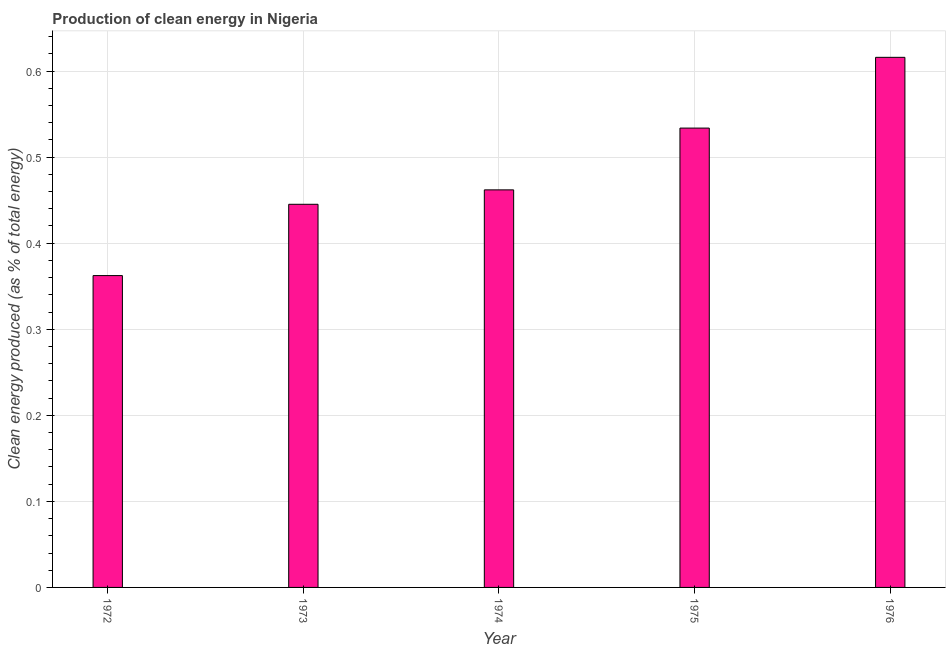Does the graph contain grids?
Your response must be concise. Yes. What is the title of the graph?
Make the answer very short. Production of clean energy in Nigeria. What is the label or title of the Y-axis?
Provide a succinct answer. Clean energy produced (as % of total energy). What is the production of clean energy in 1972?
Your response must be concise. 0.36. Across all years, what is the maximum production of clean energy?
Offer a terse response. 0.62. Across all years, what is the minimum production of clean energy?
Provide a succinct answer. 0.36. In which year was the production of clean energy maximum?
Provide a succinct answer. 1976. What is the sum of the production of clean energy?
Your answer should be very brief. 2.42. What is the difference between the production of clean energy in 1975 and 1976?
Give a very brief answer. -0.08. What is the average production of clean energy per year?
Your answer should be compact. 0.48. What is the median production of clean energy?
Give a very brief answer. 0.46. In how many years, is the production of clean energy greater than 0.4 %?
Provide a succinct answer. 4. Is the difference between the production of clean energy in 1974 and 1976 greater than the difference between any two years?
Your response must be concise. No. What is the difference between the highest and the second highest production of clean energy?
Offer a terse response. 0.08. Is the sum of the production of clean energy in 1973 and 1976 greater than the maximum production of clean energy across all years?
Provide a short and direct response. Yes. What is the difference between the highest and the lowest production of clean energy?
Keep it short and to the point. 0.25. How many bars are there?
Offer a terse response. 5. What is the difference between two consecutive major ticks on the Y-axis?
Make the answer very short. 0.1. Are the values on the major ticks of Y-axis written in scientific E-notation?
Ensure brevity in your answer.  No. What is the Clean energy produced (as % of total energy) in 1972?
Your answer should be very brief. 0.36. What is the Clean energy produced (as % of total energy) in 1973?
Keep it short and to the point. 0.45. What is the Clean energy produced (as % of total energy) in 1974?
Make the answer very short. 0.46. What is the Clean energy produced (as % of total energy) in 1975?
Your answer should be very brief. 0.53. What is the Clean energy produced (as % of total energy) in 1976?
Your response must be concise. 0.62. What is the difference between the Clean energy produced (as % of total energy) in 1972 and 1973?
Your answer should be very brief. -0.08. What is the difference between the Clean energy produced (as % of total energy) in 1972 and 1974?
Ensure brevity in your answer.  -0.1. What is the difference between the Clean energy produced (as % of total energy) in 1972 and 1975?
Offer a very short reply. -0.17. What is the difference between the Clean energy produced (as % of total energy) in 1972 and 1976?
Your response must be concise. -0.25. What is the difference between the Clean energy produced (as % of total energy) in 1973 and 1974?
Give a very brief answer. -0.02. What is the difference between the Clean energy produced (as % of total energy) in 1973 and 1975?
Provide a short and direct response. -0.09. What is the difference between the Clean energy produced (as % of total energy) in 1973 and 1976?
Offer a very short reply. -0.17. What is the difference between the Clean energy produced (as % of total energy) in 1974 and 1975?
Provide a short and direct response. -0.07. What is the difference between the Clean energy produced (as % of total energy) in 1974 and 1976?
Provide a succinct answer. -0.15. What is the difference between the Clean energy produced (as % of total energy) in 1975 and 1976?
Your answer should be very brief. -0.08. What is the ratio of the Clean energy produced (as % of total energy) in 1972 to that in 1973?
Give a very brief answer. 0.81. What is the ratio of the Clean energy produced (as % of total energy) in 1972 to that in 1974?
Offer a very short reply. 0.78. What is the ratio of the Clean energy produced (as % of total energy) in 1972 to that in 1975?
Give a very brief answer. 0.68. What is the ratio of the Clean energy produced (as % of total energy) in 1972 to that in 1976?
Ensure brevity in your answer.  0.59. What is the ratio of the Clean energy produced (as % of total energy) in 1973 to that in 1974?
Your answer should be compact. 0.96. What is the ratio of the Clean energy produced (as % of total energy) in 1973 to that in 1975?
Ensure brevity in your answer.  0.83. What is the ratio of the Clean energy produced (as % of total energy) in 1973 to that in 1976?
Your answer should be very brief. 0.72. What is the ratio of the Clean energy produced (as % of total energy) in 1974 to that in 1975?
Provide a short and direct response. 0.87. What is the ratio of the Clean energy produced (as % of total energy) in 1975 to that in 1976?
Keep it short and to the point. 0.87. 